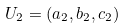Convert formula to latex. <formula><loc_0><loc_0><loc_500><loc_500>U _ { 2 } = ( a _ { 2 } , b _ { 2 } , c _ { 2 } )</formula> 